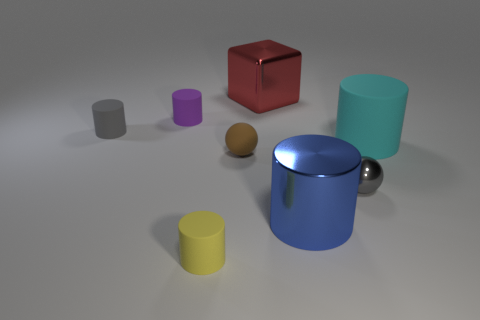There is a gray thing that is in front of the gray rubber cylinder on the left side of the sphere to the left of the red metallic cube; what size is it?
Your answer should be very brief. Small. There is a rubber thing behind the small gray object on the left side of the gray metal ball; what is its color?
Offer a very short reply. Purple. What is the material of the other object that is the same shape as the gray shiny object?
Offer a terse response. Rubber. Are there any other things that have the same material as the small gray sphere?
Ensure brevity in your answer.  Yes. There is a blue metallic cylinder; are there any red objects in front of it?
Ensure brevity in your answer.  No. What number of tiny cyan metal spheres are there?
Ensure brevity in your answer.  0. There is a rubber cylinder right of the red shiny thing; what number of cyan rubber things are on the left side of it?
Give a very brief answer. 0. Is the color of the shiny cube the same as the matte object that is to the right of the blue shiny object?
Your answer should be very brief. No. What number of other tiny metal things are the same shape as the brown object?
Keep it short and to the point. 1. What is the small sphere that is behind the tiny gray metallic object made of?
Make the answer very short. Rubber. 